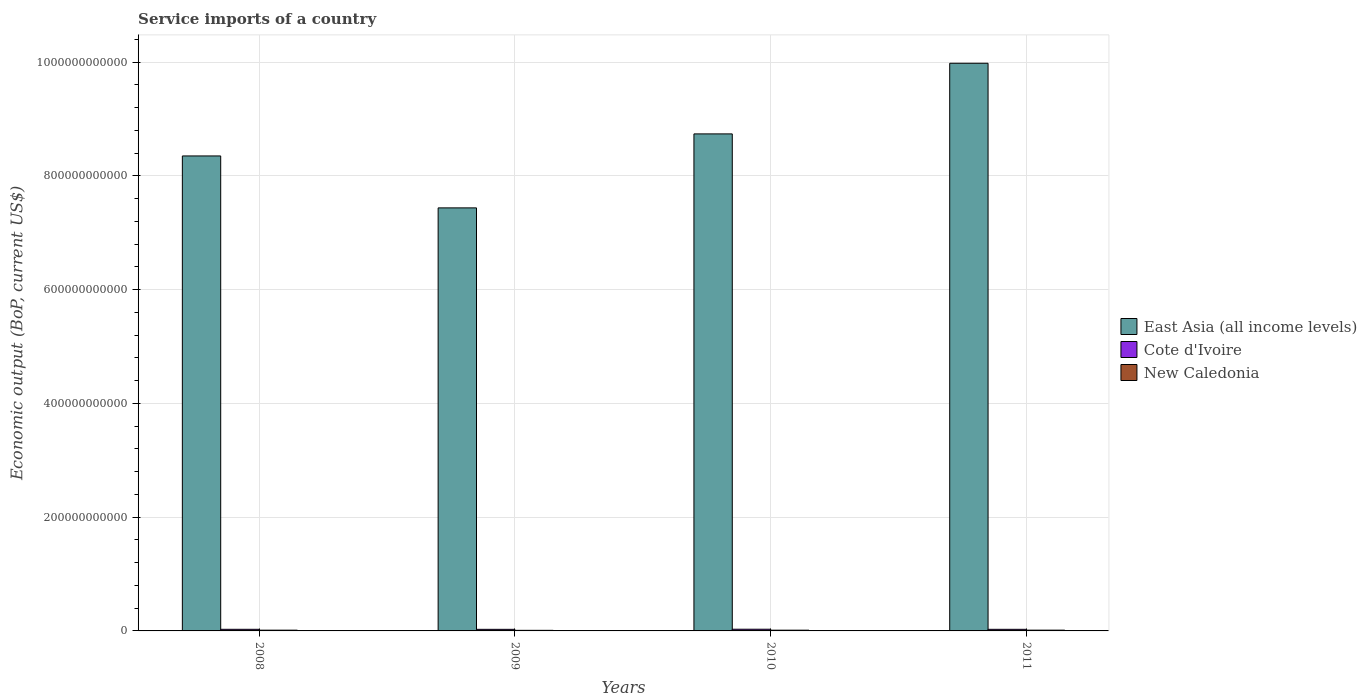How many groups of bars are there?
Your answer should be compact. 4. Are the number of bars on each tick of the X-axis equal?
Make the answer very short. Yes. What is the label of the 1st group of bars from the left?
Provide a short and direct response. 2008. What is the service imports in East Asia (all income levels) in 2009?
Provide a short and direct response. 7.44e+11. Across all years, what is the maximum service imports in New Caledonia?
Make the answer very short. 1.37e+09. Across all years, what is the minimum service imports in New Caledonia?
Keep it short and to the point. 1.04e+09. What is the total service imports in East Asia (all income levels) in the graph?
Provide a succinct answer. 3.45e+12. What is the difference between the service imports in New Caledonia in 2008 and that in 2009?
Your response must be concise. 2.78e+08. What is the difference between the service imports in Cote d'Ivoire in 2008 and the service imports in New Caledonia in 2010?
Provide a short and direct response. 1.54e+09. What is the average service imports in East Asia (all income levels) per year?
Make the answer very short. 8.63e+11. In the year 2009, what is the difference between the service imports in New Caledonia and service imports in Cote d'Ivoire?
Make the answer very short. -1.73e+09. What is the ratio of the service imports in East Asia (all income levels) in 2008 to that in 2011?
Your response must be concise. 0.84. Is the service imports in New Caledonia in 2008 less than that in 2010?
Give a very brief answer. No. What is the difference between the highest and the second highest service imports in Cote d'Ivoire?
Keep it short and to the point. 1.48e+08. What is the difference between the highest and the lowest service imports in Cote d'Ivoire?
Your answer should be very brief. 2.12e+08. In how many years, is the service imports in Cote d'Ivoire greater than the average service imports in Cote d'Ivoire taken over all years?
Offer a terse response. 1. What does the 3rd bar from the left in 2009 represents?
Offer a terse response. New Caledonia. What does the 2nd bar from the right in 2010 represents?
Your answer should be very brief. Cote d'Ivoire. Is it the case that in every year, the sum of the service imports in New Caledonia and service imports in East Asia (all income levels) is greater than the service imports in Cote d'Ivoire?
Give a very brief answer. Yes. How many bars are there?
Your answer should be compact. 12. Are all the bars in the graph horizontal?
Provide a short and direct response. No. What is the difference between two consecutive major ticks on the Y-axis?
Your response must be concise. 2.00e+11. Are the values on the major ticks of Y-axis written in scientific E-notation?
Provide a succinct answer. No. Does the graph contain grids?
Your answer should be compact. Yes. How are the legend labels stacked?
Offer a terse response. Vertical. What is the title of the graph?
Make the answer very short. Service imports of a country. What is the label or title of the Y-axis?
Provide a succinct answer. Economic output (BoP, current US$). What is the Economic output (BoP, current US$) of East Asia (all income levels) in 2008?
Give a very brief answer. 8.35e+11. What is the Economic output (BoP, current US$) in Cote d'Ivoire in 2008?
Give a very brief answer. 2.84e+09. What is the Economic output (BoP, current US$) of New Caledonia in 2008?
Keep it short and to the point. 1.32e+09. What is the Economic output (BoP, current US$) of East Asia (all income levels) in 2009?
Provide a succinct answer. 7.44e+11. What is the Economic output (BoP, current US$) in Cote d'Ivoire in 2009?
Ensure brevity in your answer.  2.78e+09. What is the Economic output (BoP, current US$) of New Caledonia in 2009?
Offer a terse response. 1.04e+09. What is the Economic output (BoP, current US$) of East Asia (all income levels) in 2010?
Provide a short and direct response. 8.74e+11. What is the Economic output (BoP, current US$) of Cote d'Ivoire in 2010?
Keep it short and to the point. 2.99e+09. What is the Economic output (BoP, current US$) of New Caledonia in 2010?
Ensure brevity in your answer.  1.30e+09. What is the Economic output (BoP, current US$) in East Asia (all income levels) in 2011?
Provide a short and direct response. 9.98e+11. What is the Economic output (BoP, current US$) of Cote d'Ivoire in 2011?
Your answer should be compact. 2.80e+09. What is the Economic output (BoP, current US$) of New Caledonia in 2011?
Make the answer very short. 1.37e+09. Across all years, what is the maximum Economic output (BoP, current US$) in East Asia (all income levels)?
Ensure brevity in your answer.  9.98e+11. Across all years, what is the maximum Economic output (BoP, current US$) of Cote d'Ivoire?
Your answer should be very brief. 2.99e+09. Across all years, what is the maximum Economic output (BoP, current US$) of New Caledonia?
Your answer should be very brief. 1.37e+09. Across all years, what is the minimum Economic output (BoP, current US$) in East Asia (all income levels)?
Provide a succinct answer. 7.44e+11. Across all years, what is the minimum Economic output (BoP, current US$) in Cote d'Ivoire?
Provide a short and direct response. 2.78e+09. Across all years, what is the minimum Economic output (BoP, current US$) in New Caledonia?
Ensure brevity in your answer.  1.04e+09. What is the total Economic output (BoP, current US$) of East Asia (all income levels) in the graph?
Provide a succinct answer. 3.45e+12. What is the total Economic output (BoP, current US$) of Cote d'Ivoire in the graph?
Your answer should be very brief. 1.14e+1. What is the total Economic output (BoP, current US$) in New Caledonia in the graph?
Offer a terse response. 5.03e+09. What is the difference between the Economic output (BoP, current US$) in East Asia (all income levels) in 2008 and that in 2009?
Make the answer very short. 9.13e+1. What is the difference between the Economic output (BoP, current US$) in Cote d'Ivoire in 2008 and that in 2009?
Your answer should be compact. 6.32e+07. What is the difference between the Economic output (BoP, current US$) in New Caledonia in 2008 and that in 2009?
Provide a succinct answer. 2.78e+08. What is the difference between the Economic output (BoP, current US$) of East Asia (all income levels) in 2008 and that in 2010?
Offer a terse response. -3.88e+1. What is the difference between the Economic output (BoP, current US$) of Cote d'Ivoire in 2008 and that in 2010?
Ensure brevity in your answer.  -1.48e+08. What is the difference between the Economic output (BoP, current US$) in New Caledonia in 2008 and that in 2010?
Your answer should be very brief. 1.78e+07. What is the difference between the Economic output (BoP, current US$) in East Asia (all income levels) in 2008 and that in 2011?
Your response must be concise. -1.63e+11. What is the difference between the Economic output (BoP, current US$) of Cote d'Ivoire in 2008 and that in 2011?
Ensure brevity in your answer.  3.73e+07. What is the difference between the Economic output (BoP, current US$) of New Caledonia in 2008 and that in 2011?
Provide a succinct answer. -5.25e+07. What is the difference between the Economic output (BoP, current US$) of East Asia (all income levels) in 2009 and that in 2010?
Ensure brevity in your answer.  -1.30e+11. What is the difference between the Economic output (BoP, current US$) in Cote d'Ivoire in 2009 and that in 2010?
Make the answer very short. -2.12e+08. What is the difference between the Economic output (BoP, current US$) in New Caledonia in 2009 and that in 2010?
Make the answer very short. -2.60e+08. What is the difference between the Economic output (BoP, current US$) in East Asia (all income levels) in 2009 and that in 2011?
Your answer should be compact. -2.54e+11. What is the difference between the Economic output (BoP, current US$) of Cote d'Ivoire in 2009 and that in 2011?
Offer a very short reply. -2.60e+07. What is the difference between the Economic output (BoP, current US$) in New Caledonia in 2009 and that in 2011?
Provide a succinct answer. -3.31e+08. What is the difference between the Economic output (BoP, current US$) in East Asia (all income levels) in 2010 and that in 2011?
Make the answer very short. -1.24e+11. What is the difference between the Economic output (BoP, current US$) of Cote d'Ivoire in 2010 and that in 2011?
Keep it short and to the point. 1.86e+08. What is the difference between the Economic output (BoP, current US$) of New Caledonia in 2010 and that in 2011?
Ensure brevity in your answer.  -7.04e+07. What is the difference between the Economic output (BoP, current US$) in East Asia (all income levels) in 2008 and the Economic output (BoP, current US$) in Cote d'Ivoire in 2009?
Your answer should be compact. 8.32e+11. What is the difference between the Economic output (BoP, current US$) of East Asia (all income levels) in 2008 and the Economic output (BoP, current US$) of New Caledonia in 2009?
Make the answer very short. 8.34e+11. What is the difference between the Economic output (BoP, current US$) of Cote d'Ivoire in 2008 and the Economic output (BoP, current US$) of New Caledonia in 2009?
Your answer should be compact. 1.80e+09. What is the difference between the Economic output (BoP, current US$) of East Asia (all income levels) in 2008 and the Economic output (BoP, current US$) of Cote d'Ivoire in 2010?
Ensure brevity in your answer.  8.32e+11. What is the difference between the Economic output (BoP, current US$) in East Asia (all income levels) in 2008 and the Economic output (BoP, current US$) in New Caledonia in 2010?
Provide a succinct answer. 8.34e+11. What is the difference between the Economic output (BoP, current US$) in Cote d'Ivoire in 2008 and the Economic output (BoP, current US$) in New Caledonia in 2010?
Provide a succinct answer. 1.54e+09. What is the difference between the Economic output (BoP, current US$) of East Asia (all income levels) in 2008 and the Economic output (BoP, current US$) of Cote d'Ivoire in 2011?
Make the answer very short. 8.32e+11. What is the difference between the Economic output (BoP, current US$) of East Asia (all income levels) in 2008 and the Economic output (BoP, current US$) of New Caledonia in 2011?
Provide a succinct answer. 8.34e+11. What is the difference between the Economic output (BoP, current US$) in Cote d'Ivoire in 2008 and the Economic output (BoP, current US$) in New Caledonia in 2011?
Keep it short and to the point. 1.47e+09. What is the difference between the Economic output (BoP, current US$) in East Asia (all income levels) in 2009 and the Economic output (BoP, current US$) in Cote d'Ivoire in 2010?
Offer a very short reply. 7.41e+11. What is the difference between the Economic output (BoP, current US$) in East Asia (all income levels) in 2009 and the Economic output (BoP, current US$) in New Caledonia in 2010?
Your response must be concise. 7.42e+11. What is the difference between the Economic output (BoP, current US$) of Cote d'Ivoire in 2009 and the Economic output (BoP, current US$) of New Caledonia in 2010?
Your response must be concise. 1.47e+09. What is the difference between the Economic output (BoP, current US$) of East Asia (all income levels) in 2009 and the Economic output (BoP, current US$) of Cote d'Ivoire in 2011?
Offer a terse response. 7.41e+11. What is the difference between the Economic output (BoP, current US$) in East Asia (all income levels) in 2009 and the Economic output (BoP, current US$) in New Caledonia in 2011?
Ensure brevity in your answer.  7.42e+11. What is the difference between the Economic output (BoP, current US$) of Cote d'Ivoire in 2009 and the Economic output (BoP, current US$) of New Caledonia in 2011?
Make the answer very short. 1.40e+09. What is the difference between the Economic output (BoP, current US$) in East Asia (all income levels) in 2010 and the Economic output (BoP, current US$) in Cote d'Ivoire in 2011?
Your answer should be very brief. 8.71e+11. What is the difference between the Economic output (BoP, current US$) in East Asia (all income levels) in 2010 and the Economic output (BoP, current US$) in New Caledonia in 2011?
Your response must be concise. 8.72e+11. What is the difference between the Economic output (BoP, current US$) of Cote d'Ivoire in 2010 and the Economic output (BoP, current US$) of New Caledonia in 2011?
Offer a terse response. 1.62e+09. What is the average Economic output (BoP, current US$) of East Asia (all income levels) per year?
Ensure brevity in your answer.  8.63e+11. What is the average Economic output (BoP, current US$) of Cote d'Ivoire per year?
Give a very brief answer. 2.85e+09. What is the average Economic output (BoP, current US$) in New Caledonia per year?
Give a very brief answer. 1.26e+09. In the year 2008, what is the difference between the Economic output (BoP, current US$) of East Asia (all income levels) and Economic output (BoP, current US$) of Cote d'Ivoire?
Keep it short and to the point. 8.32e+11. In the year 2008, what is the difference between the Economic output (BoP, current US$) of East Asia (all income levels) and Economic output (BoP, current US$) of New Caledonia?
Keep it short and to the point. 8.34e+11. In the year 2008, what is the difference between the Economic output (BoP, current US$) in Cote d'Ivoire and Economic output (BoP, current US$) in New Caledonia?
Give a very brief answer. 1.52e+09. In the year 2009, what is the difference between the Economic output (BoP, current US$) in East Asia (all income levels) and Economic output (BoP, current US$) in Cote d'Ivoire?
Your answer should be compact. 7.41e+11. In the year 2009, what is the difference between the Economic output (BoP, current US$) in East Asia (all income levels) and Economic output (BoP, current US$) in New Caledonia?
Give a very brief answer. 7.43e+11. In the year 2009, what is the difference between the Economic output (BoP, current US$) in Cote d'Ivoire and Economic output (BoP, current US$) in New Caledonia?
Offer a terse response. 1.73e+09. In the year 2010, what is the difference between the Economic output (BoP, current US$) of East Asia (all income levels) and Economic output (BoP, current US$) of Cote d'Ivoire?
Your answer should be compact. 8.71e+11. In the year 2010, what is the difference between the Economic output (BoP, current US$) in East Asia (all income levels) and Economic output (BoP, current US$) in New Caledonia?
Keep it short and to the point. 8.73e+11. In the year 2010, what is the difference between the Economic output (BoP, current US$) in Cote d'Ivoire and Economic output (BoP, current US$) in New Caledonia?
Your response must be concise. 1.69e+09. In the year 2011, what is the difference between the Economic output (BoP, current US$) in East Asia (all income levels) and Economic output (BoP, current US$) in Cote d'Ivoire?
Your response must be concise. 9.95e+11. In the year 2011, what is the difference between the Economic output (BoP, current US$) in East Asia (all income levels) and Economic output (BoP, current US$) in New Caledonia?
Your response must be concise. 9.97e+11. In the year 2011, what is the difference between the Economic output (BoP, current US$) in Cote d'Ivoire and Economic output (BoP, current US$) in New Caledonia?
Offer a terse response. 1.43e+09. What is the ratio of the Economic output (BoP, current US$) in East Asia (all income levels) in 2008 to that in 2009?
Your answer should be compact. 1.12. What is the ratio of the Economic output (BoP, current US$) of Cote d'Ivoire in 2008 to that in 2009?
Provide a short and direct response. 1.02. What is the ratio of the Economic output (BoP, current US$) of New Caledonia in 2008 to that in 2009?
Keep it short and to the point. 1.27. What is the ratio of the Economic output (BoP, current US$) in East Asia (all income levels) in 2008 to that in 2010?
Your answer should be compact. 0.96. What is the ratio of the Economic output (BoP, current US$) of Cote d'Ivoire in 2008 to that in 2010?
Keep it short and to the point. 0.95. What is the ratio of the Economic output (BoP, current US$) in New Caledonia in 2008 to that in 2010?
Provide a short and direct response. 1.01. What is the ratio of the Economic output (BoP, current US$) in East Asia (all income levels) in 2008 to that in 2011?
Make the answer very short. 0.84. What is the ratio of the Economic output (BoP, current US$) of Cote d'Ivoire in 2008 to that in 2011?
Offer a terse response. 1.01. What is the ratio of the Economic output (BoP, current US$) of New Caledonia in 2008 to that in 2011?
Offer a very short reply. 0.96. What is the ratio of the Economic output (BoP, current US$) of East Asia (all income levels) in 2009 to that in 2010?
Provide a succinct answer. 0.85. What is the ratio of the Economic output (BoP, current US$) of Cote d'Ivoire in 2009 to that in 2010?
Your response must be concise. 0.93. What is the ratio of the Economic output (BoP, current US$) in East Asia (all income levels) in 2009 to that in 2011?
Offer a very short reply. 0.75. What is the ratio of the Economic output (BoP, current US$) of New Caledonia in 2009 to that in 2011?
Provide a succinct answer. 0.76. What is the ratio of the Economic output (BoP, current US$) of East Asia (all income levels) in 2010 to that in 2011?
Keep it short and to the point. 0.88. What is the ratio of the Economic output (BoP, current US$) in Cote d'Ivoire in 2010 to that in 2011?
Provide a succinct answer. 1.07. What is the ratio of the Economic output (BoP, current US$) of New Caledonia in 2010 to that in 2011?
Your answer should be compact. 0.95. What is the difference between the highest and the second highest Economic output (BoP, current US$) in East Asia (all income levels)?
Make the answer very short. 1.24e+11. What is the difference between the highest and the second highest Economic output (BoP, current US$) of Cote d'Ivoire?
Give a very brief answer. 1.48e+08. What is the difference between the highest and the second highest Economic output (BoP, current US$) of New Caledonia?
Make the answer very short. 5.25e+07. What is the difference between the highest and the lowest Economic output (BoP, current US$) in East Asia (all income levels)?
Keep it short and to the point. 2.54e+11. What is the difference between the highest and the lowest Economic output (BoP, current US$) in Cote d'Ivoire?
Provide a short and direct response. 2.12e+08. What is the difference between the highest and the lowest Economic output (BoP, current US$) in New Caledonia?
Provide a succinct answer. 3.31e+08. 